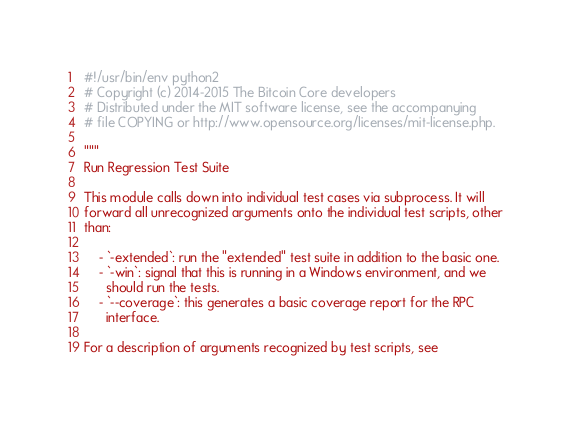<code> <loc_0><loc_0><loc_500><loc_500><_Python_>#!/usr/bin/env python2
# Copyright (c) 2014-2015 The Bitcoin Core developers
# Distributed under the MIT software license, see the accompanying
# file COPYING or http://www.opensource.org/licenses/mit-license.php.

"""
Run Regression Test Suite

This module calls down into individual test cases via subprocess. It will
forward all unrecognized arguments onto the individual test scripts, other
than:

    - `-extended`: run the "extended" test suite in addition to the basic one.
    - `-win`: signal that this is running in a Windows environment, and we
      should run the tests.
    - `--coverage`: this generates a basic coverage report for the RPC
      interface.

For a description of arguments recognized by test scripts, see</code> 